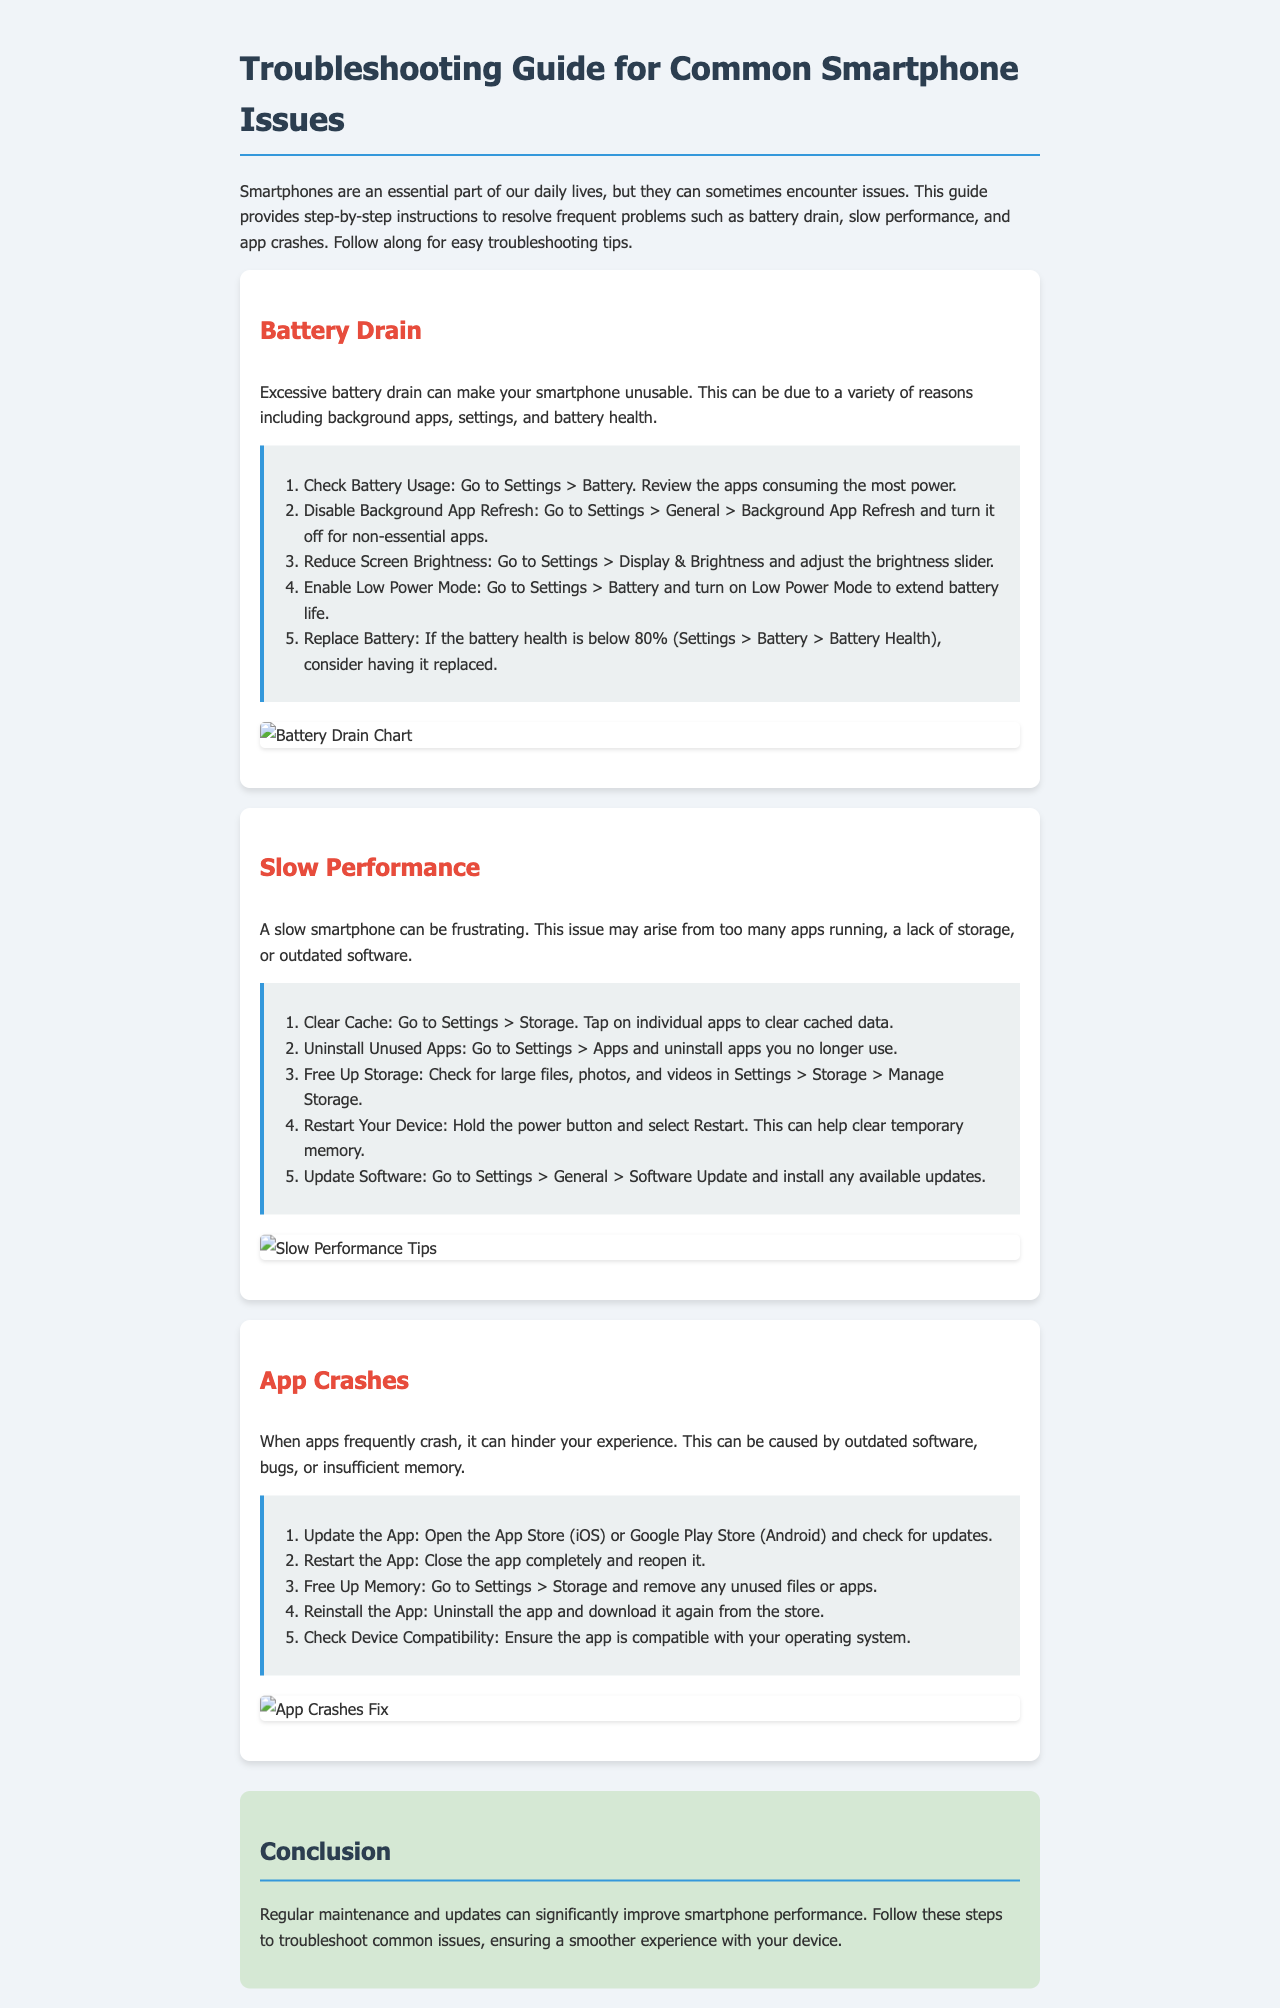What is one of the frequent problems addressed in this guide? The guide addresses common smartphone issues, specifically mentioning battery drain, slow performance, and app crashes.
Answer: Battery drain How many steps are provided for troubleshooting slow performance? The section on slow performance lists five specific steps to help resolve the issue.
Answer: Five What should be done if battery health is below a certain percentage? The document advises replacing the battery if its health is below 80%.
Answer: Replace battery What is the first step to resolve app crashes? The initial step for addressing app crashes is to update the app via the respective app store.
Answer: Update the App Which mode can be enabled to extend battery life? The guide suggests turning on Low Power Mode to help prolong battery life.
Answer: Low Power Mode What type of visual aid is included for battery drain? The document includes a visual aid in the form of a chart specifically related to battery drain.
Answer: Battery Drain Chart Which settings path leads to adjust screen brightness? The path to reduce screen brightness is found under Settings > Display & Brightness.
Answer: Settings > Display & Brightness How often should regular maintenance be conducted according to the conclusion? While the document doesn't specify a frequency, it implies that regular maintenance and updates should be performed consistently.
Answer: Regularly 